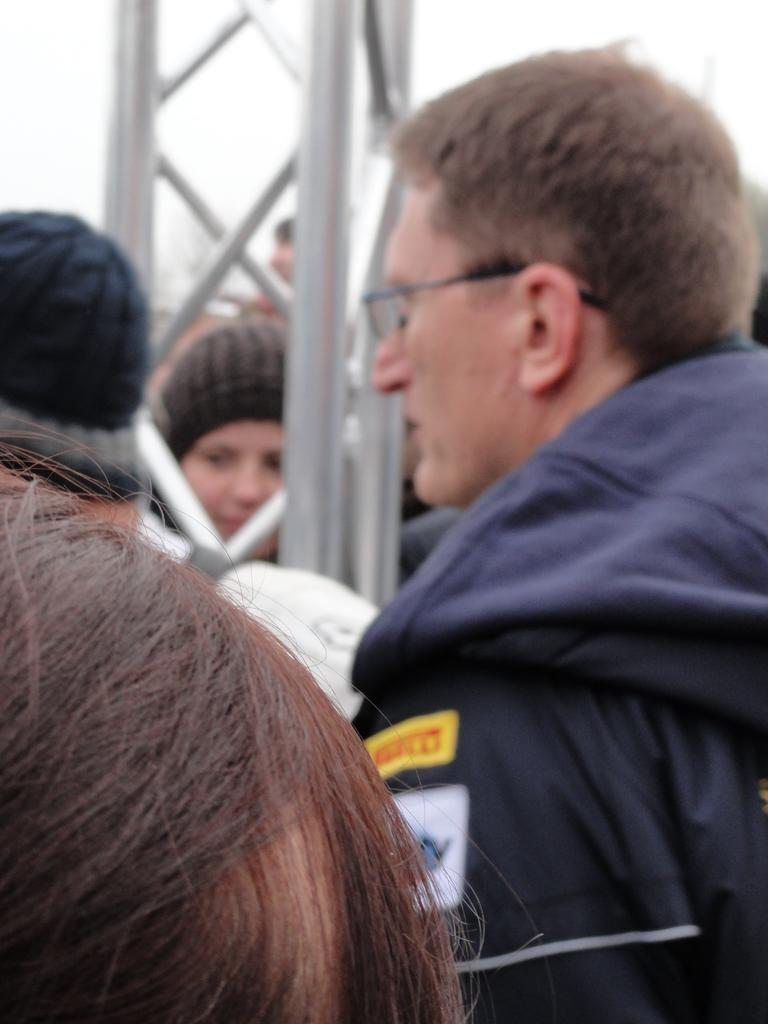Who or what can be seen at the bottom of the image? There are people at the bottom of the image. What structure is located in the middle of the image? There is a tower in the middle of the image. What is visible in the background of the image? The sky is visible in the background of the image. How much money is being exchanged between the people at the bottom of the image? There is no indication of money or any exchange in the image; it only shows people and a tower. What position does the church hold in relation to the tower in the image? There is no church present in the image, so it is not possible to determine its position relative to the tower. 